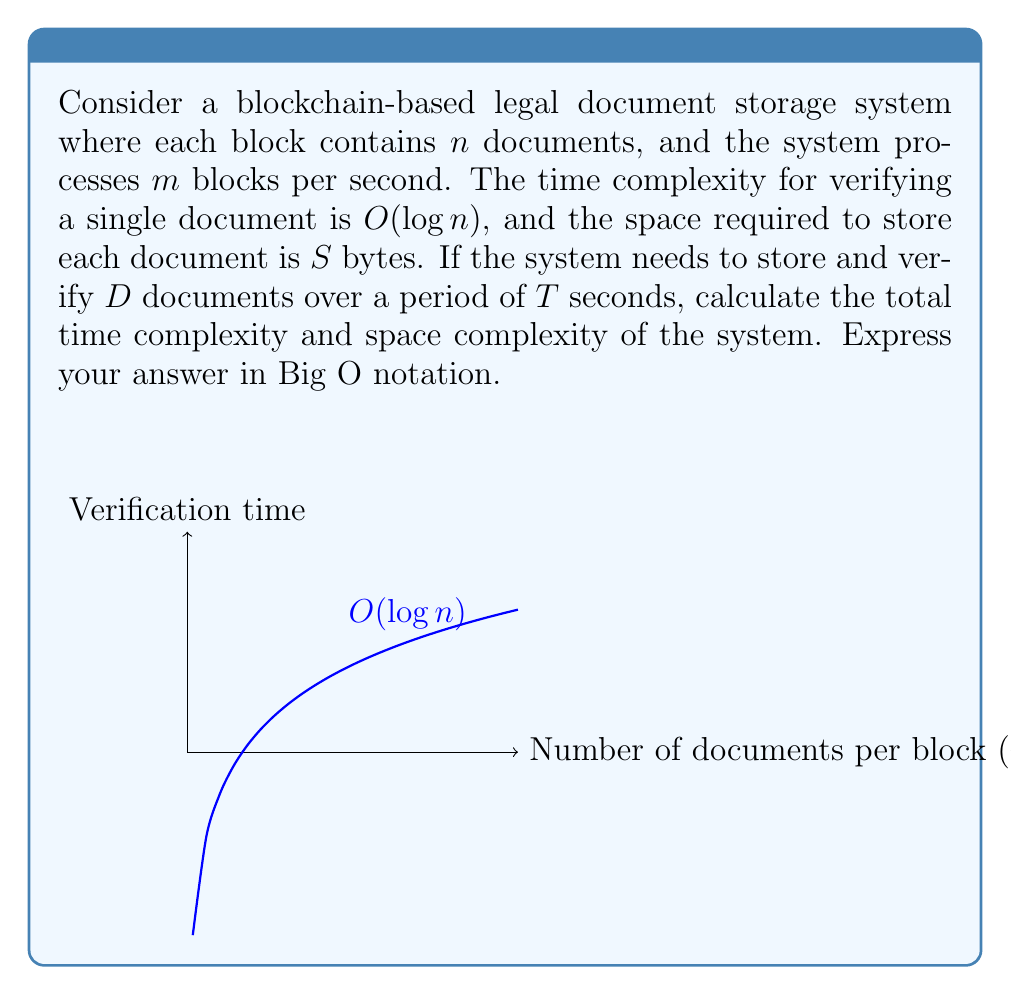What is the answer to this math problem? Let's break this down step by step:

1) Time complexity:
   - For each block, we need to verify $n$ documents.
   - Verifying a single document takes $O(\log n)$ time.
   - So, verifying all documents in one block takes $O(n \log n)$ time.
   - In one second, we process $m$ blocks, so the time complexity per second is $O(mn \log n)$.
   - Over $T$ seconds, the total time complexity is $O(Tmn \log n)$.

2) Space complexity:
   - Each document requires $S$ bytes of storage.
   - We need to store $D$ documents in total.
   - So, the total space required is $O(DS)$.

3) Relating $D$, $T$, $m$, and $n$:
   - In $T$ seconds, we process $Tm$ blocks.
   - Each block contains $n$ documents.
   - So, the total number of documents processed is $Tmn$.
   - This should equal $D$: $D = Tmn$

4) Substituting this into our time complexity:
   $O(Tmn \log n) = O(D \log n)$

Therefore, the final complexities are:
- Time complexity: $O(D \log n)$
- Space complexity: $O(DS)$

Where $D$ is the total number of documents, $n$ is the number of documents per block, and $S$ is the size of each document in bytes.
Answer: Time: $O(D \log n)$, Space: $O(DS)$ 